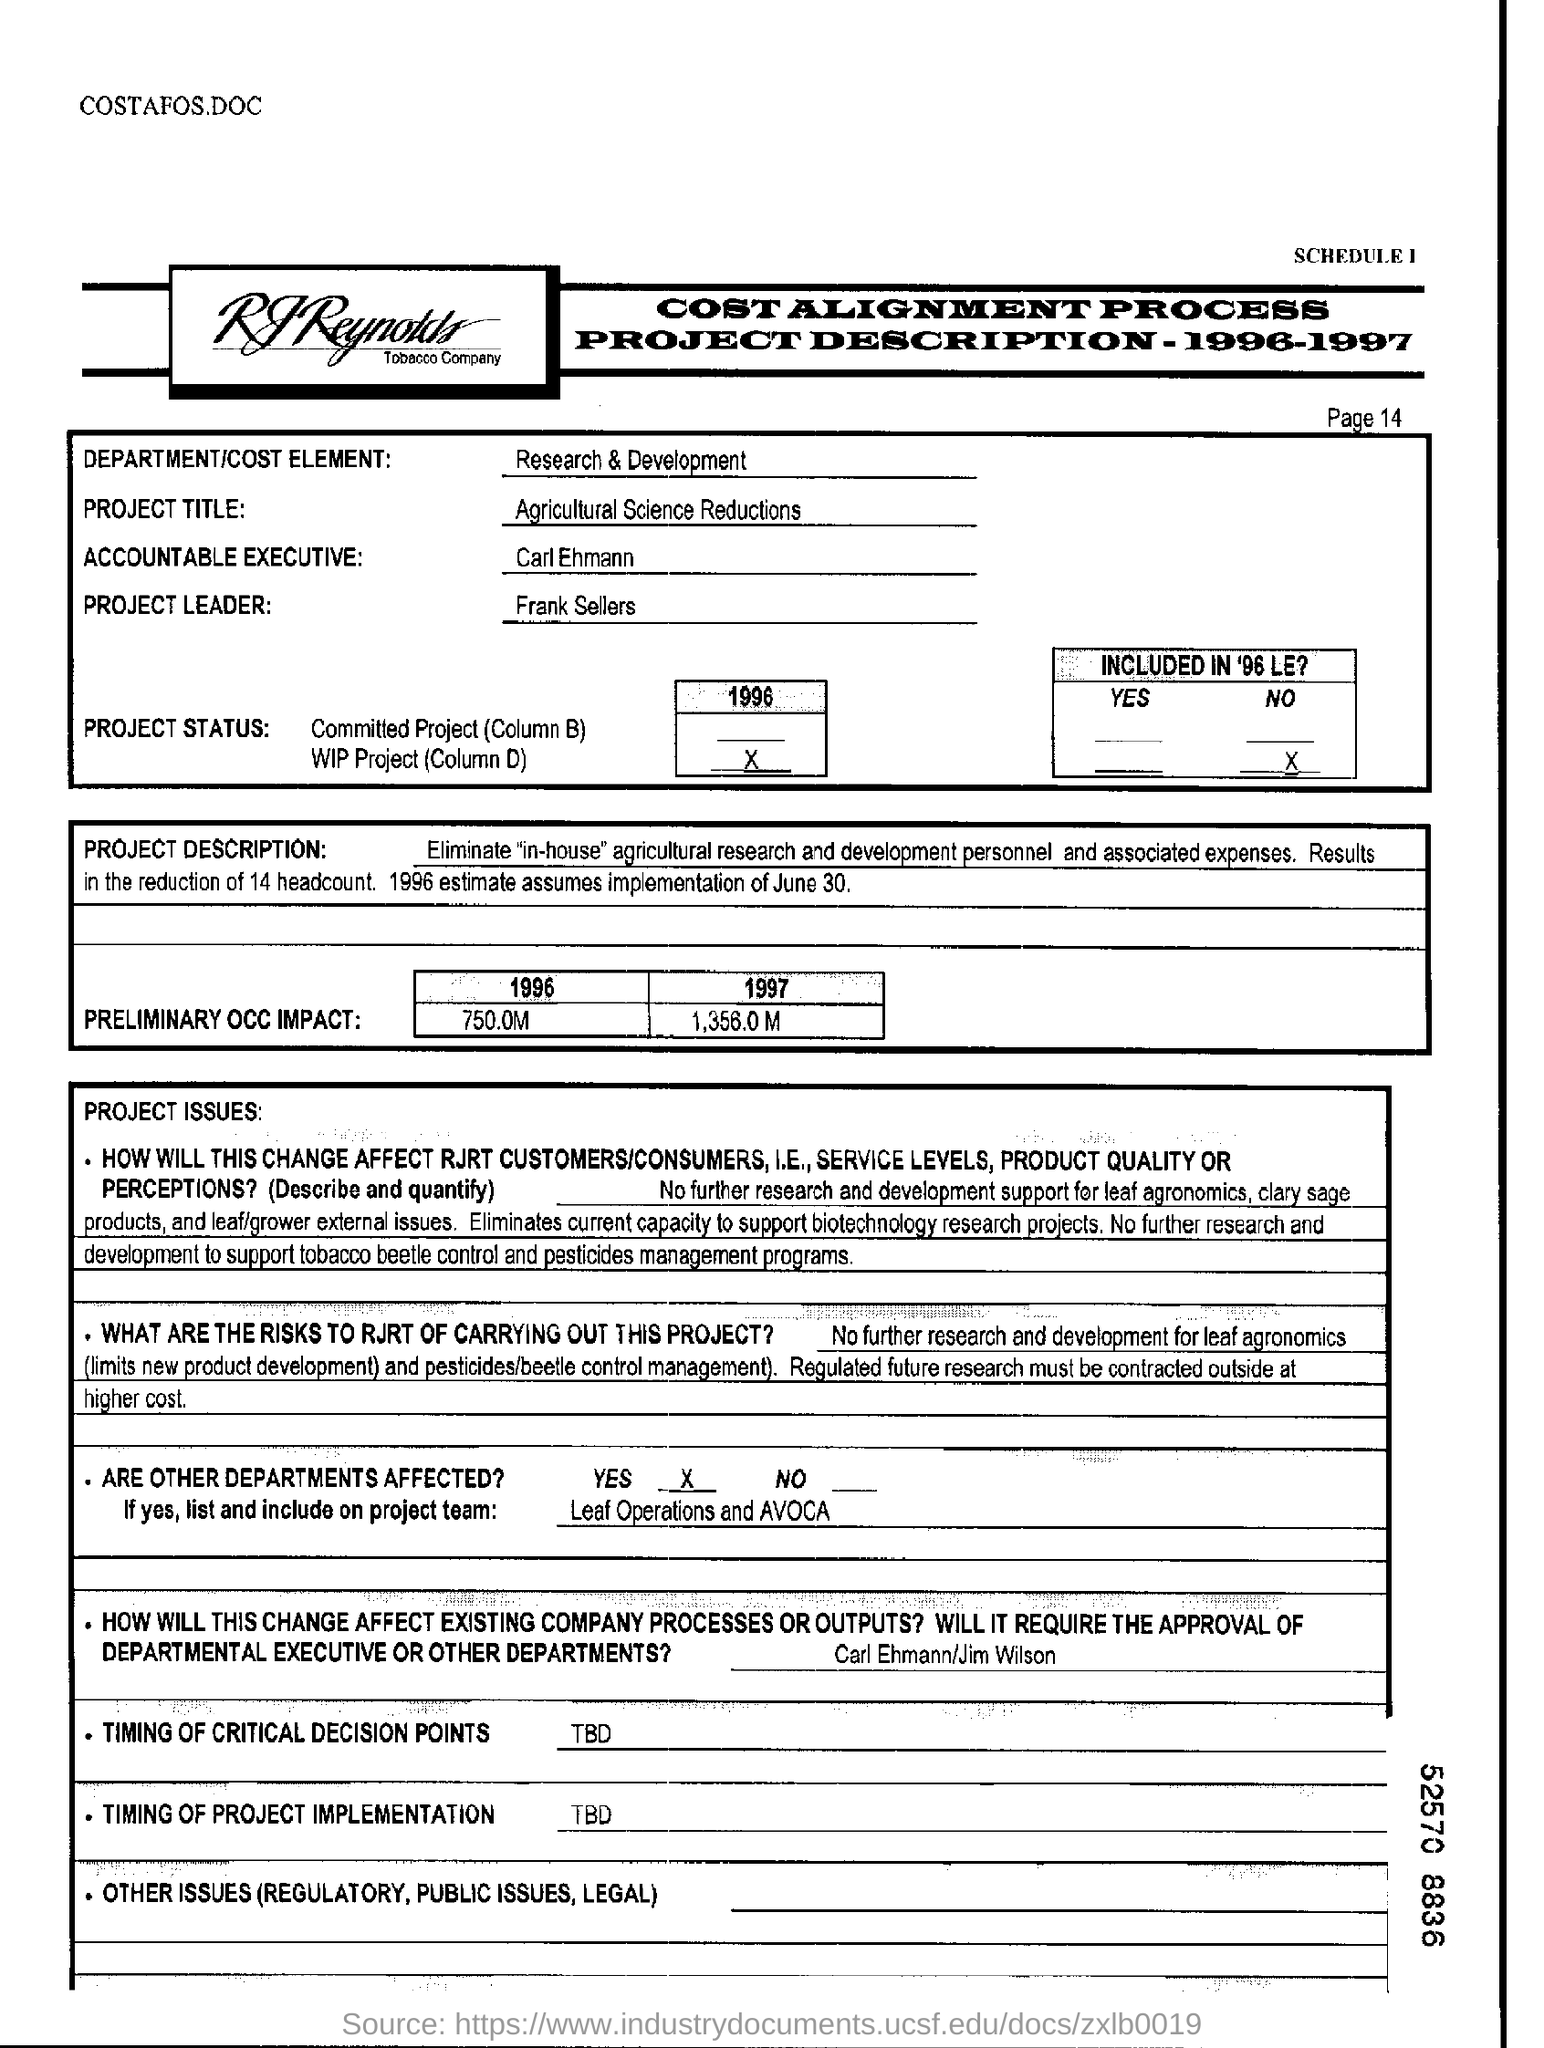Identify some key points in this picture. In the year 1997, there was a preliminary estimated impact of 1,356.0 million tons of CO2 emissions. The project leader is Frank Sellers. The assumed date of implementation is June 30, 1996, as estimated by [source]. The project title is Agricultural Science Reductions, which aims to achieve reductions in greenhouse gas emissions from the agricultural sector through the implementation of innovative and sustainable practices. Yes, there are other departments that have been affected. 